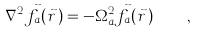Convert formula to latex. <formula><loc_0><loc_0><loc_500><loc_500>\nabla ^ { 2 } \vec { f } _ { a } ( \vec { r } \, ) = - \Omega _ { a } ^ { 2 } \vec { f } _ { a } ( \vec { r } \, ) \quad ,</formula> 